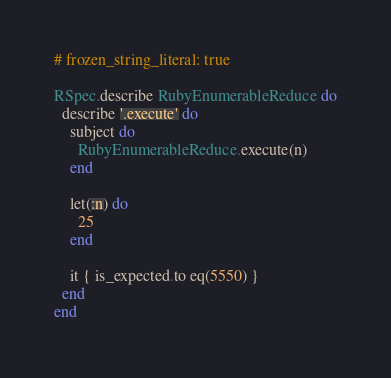Convert code to text. <code><loc_0><loc_0><loc_500><loc_500><_Ruby_># frozen_string_literal: true

RSpec.describe RubyEnumerableReduce do
  describe '.execute' do
    subject do
      RubyEnumerableReduce.execute(n)
    end

    let(:n) do
      25
    end

    it { is_expected.to eq(5550) }
  end
end
</code> 